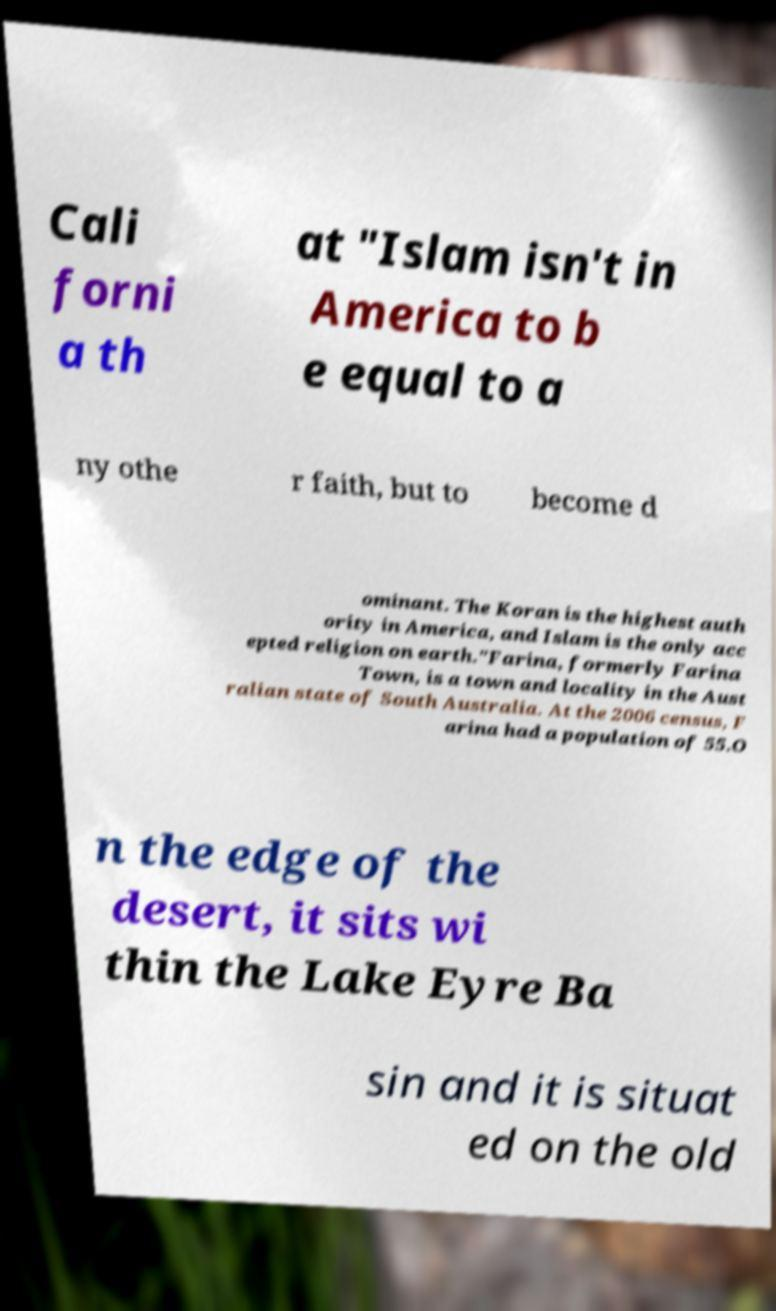Can you accurately transcribe the text from the provided image for me? Cali forni a th at "Islam isn't in America to b e equal to a ny othe r faith, but to become d ominant. The Koran is the highest auth ority in America, and Islam is the only acc epted religion on earth."Farina, formerly Farina Town, is a town and locality in the Aust ralian state of South Australia. At the 2006 census, F arina had a population of 55.O n the edge of the desert, it sits wi thin the Lake Eyre Ba sin and it is situat ed on the old 